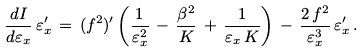<formula> <loc_0><loc_0><loc_500><loc_500>\frac { d I } { d \varepsilon _ { x } } \, \varepsilon _ { x } ^ { \prime } \, = \, ( f ^ { 2 } ) ^ { \prime } \left ( \frac { 1 } { \varepsilon _ { x } ^ { 2 } } \, - \, \frac { \beta ^ { 2 } } { K } \, + \, \frac { 1 } { \varepsilon _ { x } \, K } \right ) \, - \, \frac { 2 \, f ^ { 2 } } { \varepsilon _ { x } ^ { 3 } } \, \varepsilon _ { x } ^ { \prime } \, .</formula> 